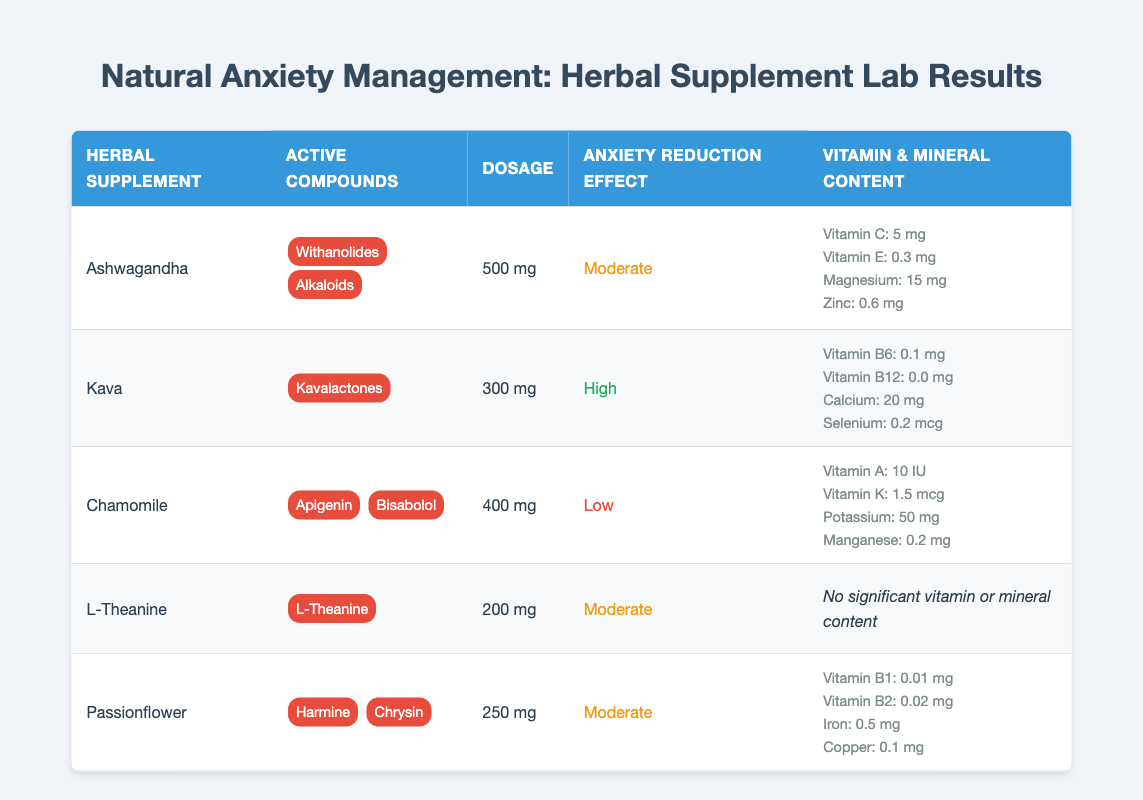What are the active compounds in Kava? The table lists Kava and shows that its active compound is Kavalactones.
Answer: Kavalactones Which herbal supplement has the highest anxiety reduction effect? Looking at the "Anxiety Reduction Effect" column, Kava has a "High" effect while the others are either "Moderate" or "Low."
Answer: Kava How much Vitamin C is found in Ashwagandha? The table indicates that Ashwagandha contains 5 mg of Vitamin C under the "Vitamin Content" section.
Answer: 5 mg What is the total dosage of herbal supplements with a moderate anxiety reduction effect? The dosages for Ashwagandha (500 mg), L-Theanine (200 mg), and Passionflower (250 mg) with "Moderate" effect need to be summed up: 500 + 200 + 250 = 950 mg.
Answer: 950 mg Does Chamomile have any active compounds listed in the table? The active compounds listed for Chamomile are Apigenin and Bisabolol, according to the table.
Answer: Yes Which herbal supplement contains the highest magnesium content? Reviewing the "Mineral Content" of each herbal supplement: Ashwagandha has 15 mg of Magnesium, which is the only entry for Magnesium, suggesting it is the highest.
Answer: Ashwagandha What is the average dosage of the herbal supplements listed? The dosages are 500 mg (Ashwagandha), 300 mg (Kava), 400 mg (Chamomile), 200 mg (L-Theanine), and 250 mg (Passionflower). To get the average, first sum: 500 + 300 + 400 + 200 + 250 = 1650 mg. Then, divide by the number of supplements (5): 1650/5 = 330 mg.
Answer: 330 mg Is there any herbal supplement in the table that has no vitamins or minerals listed? The table indicates that L-Theanine has no significant vitamin or mineral content.
Answer: Yes How does the anxiety reduction effect of Passionflower compare to that of Chamomile? Passionflower has a "Moderate" anxiety reduction effect, while Chamomile has a "Low" effect, making Passionflower more effective concerning anxiety reduction than Chamomile.
Answer: Passionflower is more effective 